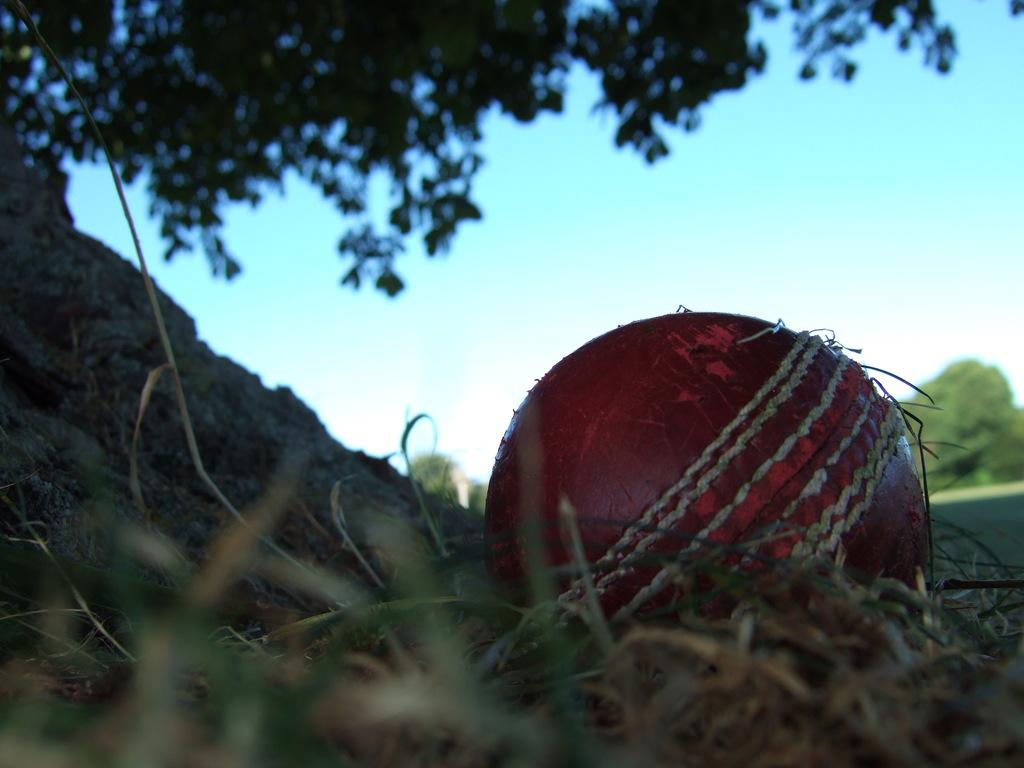What object is present in the image? There is a ball in the image. What type of surface is the ball on? There is grass in the image, which is the surface the ball is on. What can be seen in the background of the image? There are trees and the sky visible in the background of the image. How many crates are stacked next to the woman in the image? There is no woman or crate present in the image. 